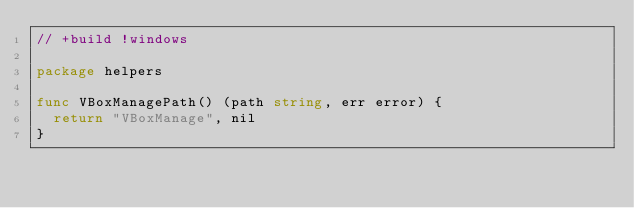Convert code to text. <code><loc_0><loc_0><loc_500><loc_500><_Go_>// +build !windows

package helpers

func VBoxManagePath() (path string, err error) {
	return "VBoxManage", nil
}
</code> 